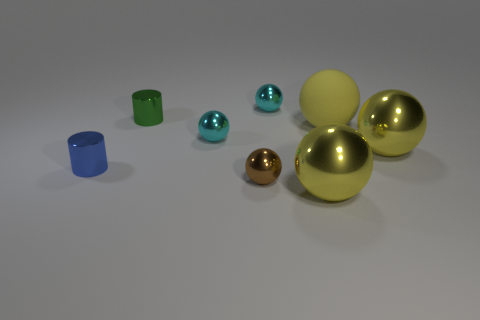How many yellow balls must be subtracted to get 1 yellow balls? 2 Add 2 cylinders. How many objects exist? 10 Subtract all matte spheres. How many spheres are left? 5 Add 6 cyan metallic spheres. How many cyan metallic spheres exist? 8 Subtract all green cylinders. How many cylinders are left? 1 Subtract 1 blue cylinders. How many objects are left? 7 Subtract all cylinders. How many objects are left? 6 Subtract all brown spheres. Subtract all yellow cubes. How many spheres are left? 5 Subtract all brown cubes. How many cyan balls are left? 2 Subtract all cyan metallic spheres. Subtract all rubber things. How many objects are left? 5 